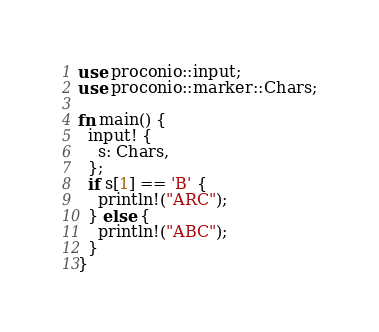<code> <loc_0><loc_0><loc_500><loc_500><_Rust_>use proconio::input;
use proconio::marker::Chars;

fn main() {
  input! {
    s: Chars,
  };
  if s[1] == 'B' {
    println!("ARC");
  } else {
    println!("ABC");
  }
}</code> 